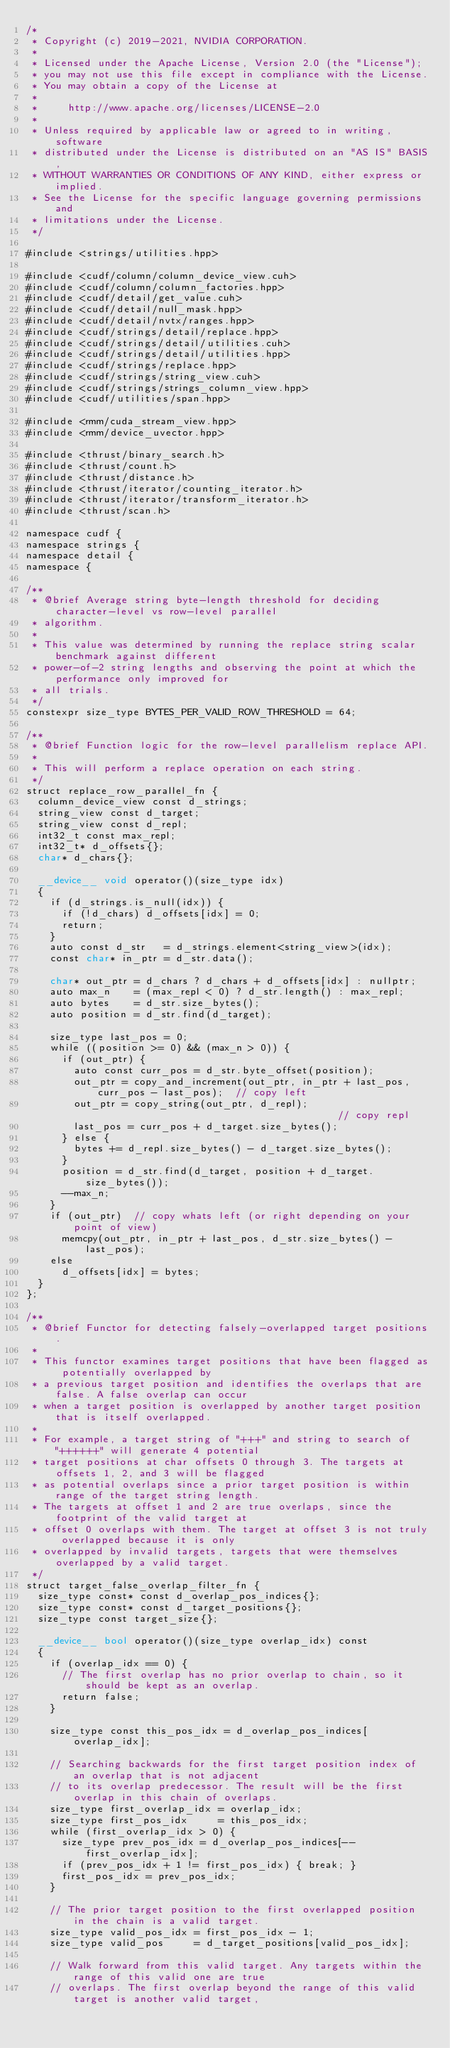Convert code to text. <code><loc_0><loc_0><loc_500><loc_500><_Cuda_>/*
 * Copyright (c) 2019-2021, NVIDIA CORPORATION.
 *
 * Licensed under the Apache License, Version 2.0 (the "License");
 * you may not use this file except in compliance with the License.
 * You may obtain a copy of the License at
 *
 *     http://www.apache.org/licenses/LICENSE-2.0
 *
 * Unless required by applicable law or agreed to in writing, software
 * distributed under the License is distributed on an "AS IS" BASIS,
 * WITHOUT WARRANTIES OR CONDITIONS OF ANY KIND, either express or implied.
 * See the License for the specific language governing permissions and
 * limitations under the License.
 */

#include <strings/utilities.hpp>

#include <cudf/column/column_device_view.cuh>
#include <cudf/column/column_factories.hpp>
#include <cudf/detail/get_value.cuh>
#include <cudf/detail/null_mask.hpp>
#include <cudf/detail/nvtx/ranges.hpp>
#include <cudf/strings/detail/replace.hpp>
#include <cudf/strings/detail/utilities.cuh>
#include <cudf/strings/detail/utilities.hpp>
#include <cudf/strings/replace.hpp>
#include <cudf/strings/string_view.cuh>
#include <cudf/strings/strings_column_view.hpp>
#include <cudf/utilities/span.hpp>

#include <rmm/cuda_stream_view.hpp>
#include <rmm/device_uvector.hpp>

#include <thrust/binary_search.h>
#include <thrust/count.h>
#include <thrust/distance.h>
#include <thrust/iterator/counting_iterator.h>
#include <thrust/iterator/transform_iterator.h>
#include <thrust/scan.h>

namespace cudf {
namespace strings {
namespace detail {
namespace {

/**
 * @brief Average string byte-length threshold for deciding character-level vs row-level parallel
 * algorithm.
 *
 * This value was determined by running the replace string scalar benchmark against different
 * power-of-2 string lengths and observing the point at which the performance only improved for
 * all trials.
 */
constexpr size_type BYTES_PER_VALID_ROW_THRESHOLD = 64;

/**
 * @brief Function logic for the row-level parallelism replace API.
 *
 * This will perform a replace operation on each string.
 */
struct replace_row_parallel_fn {
  column_device_view const d_strings;
  string_view const d_target;
  string_view const d_repl;
  int32_t const max_repl;
  int32_t* d_offsets{};
  char* d_chars{};

  __device__ void operator()(size_type idx)
  {
    if (d_strings.is_null(idx)) {
      if (!d_chars) d_offsets[idx] = 0;
      return;
    }
    auto const d_str   = d_strings.element<string_view>(idx);
    const char* in_ptr = d_str.data();

    char* out_ptr = d_chars ? d_chars + d_offsets[idx] : nullptr;
    auto max_n    = (max_repl < 0) ? d_str.length() : max_repl;
    auto bytes    = d_str.size_bytes();
    auto position = d_str.find(d_target);

    size_type last_pos = 0;
    while ((position >= 0) && (max_n > 0)) {
      if (out_ptr) {
        auto const curr_pos = d_str.byte_offset(position);
        out_ptr = copy_and_increment(out_ptr, in_ptr + last_pos, curr_pos - last_pos);  // copy left
        out_ptr = copy_string(out_ptr, d_repl);                                         // copy repl
        last_pos = curr_pos + d_target.size_bytes();
      } else {
        bytes += d_repl.size_bytes() - d_target.size_bytes();
      }
      position = d_str.find(d_target, position + d_target.size_bytes());
      --max_n;
    }
    if (out_ptr)  // copy whats left (or right depending on your point of view)
      memcpy(out_ptr, in_ptr + last_pos, d_str.size_bytes() - last_pos);
    else
      d_offsets[idx] = bytes;
  }
};

/**
 * @brief Functor for detecting falsely-overlapped target positions.
 *
 * This functor examines target positions that have been flagged as potentially overlapped by
 * a previous target position and identifies the overlaps that are false. A false overlap can occur
 * when a target position is overlapped by another target position that is itself overlapped.
 *
 * For example, a target string of "+++" and string to search of "++++++" will generate 4 potential
 * target positions at char offsets 0 through 3. The targets at offsets 1, 2, and 3 will be flagged
 * as potential overlaps since a prior target position is within range of the target string length.
 * The targets at offset 1 and 2 are true overlaps, since the footprint of the valid target at
 * offset 0 overlaps with them. The target at offset 3 is not truly overlapped because it is only
 * overlapped by invalid targets, targets that were themselves overlapped by a valid target.
 */
struct target_false_overlap_filter_fn {
  size_type const* const d_overlap_pos_indices{};
  size_type const* const d_target_positions{};
  size_type const target_size{};

  __device__ bool operator()(size_type overlap_idx) const
  {
    if (overlap_idx == 0) {
      // The first overlap has no prior overlap to chain, so it should be kept as an overlap.
      return false;
    }

    size_type const this_pos_idx = d_overlap_pos_indices[overlap_idx];

    // Searching backwards for the first target position index of an overlap that is not adjacent
    // to its overlap predecessor. The result will be the first overlap in this chain of overlaps.
    size_type first_overlap_idx = overlap_idx;
    size_type first_pos_idx     = this_pos_idx;
    while (first_overlap_idx > 0) {
      size_type prev_pos_idx = d_overlap_pos_indices[--first_overlap_idx];
      if (prev_pos_idx + 1 != first_pos_idx) { break; }
      first_pos_idx = prev_pos_idx;
    }

    // The prior target position to the first overlapped position in the chain is a valid target.
    size_type valid_pos_idx = first_pos_idx - 1;
    size_type valid_pos     = d_target_positions[valid_pos_idx];

    // Walk forward from this valid target. Any targets within the range of this valid one are true
    // overlaps. The first overlap beyond the range of this valid target is another valid target,</code> 